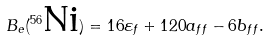<formula> <loc_0><loc_0><loc_500><loc_500>B _ { e } ( ^ { 5 6 } \text {Ni} ) = 1 6 \varepsilon _ { f } + 1 2 0 a _ { f f } - 6 b _ { f f } .</formula> 